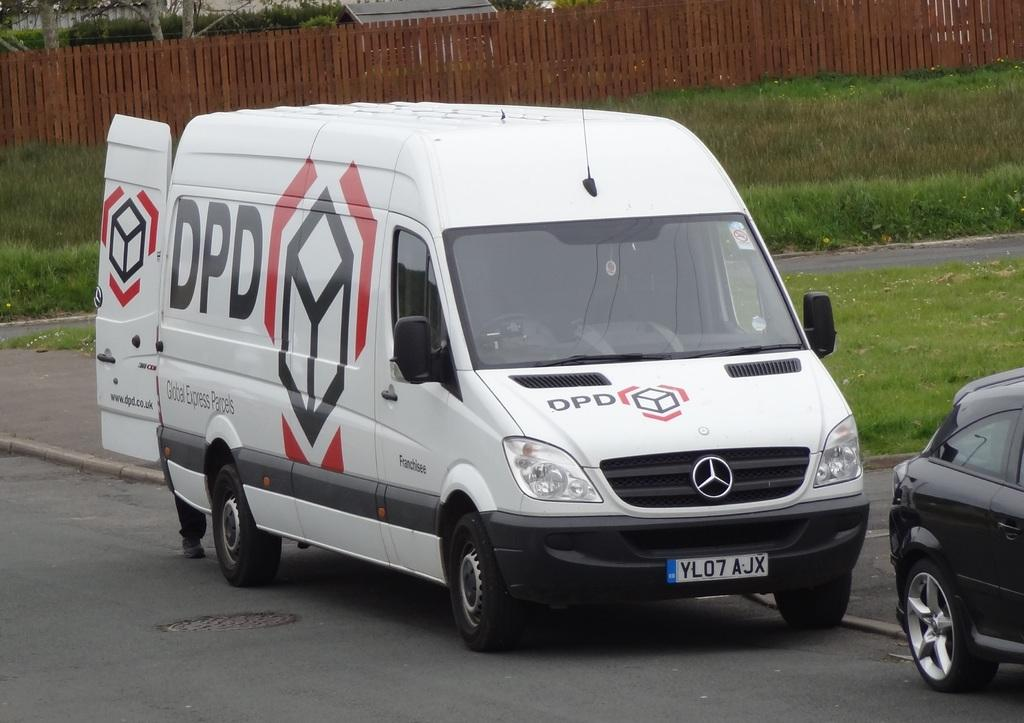<image>
Describe the image concisely. A white company van says DPD on the side and the back doors are open. 